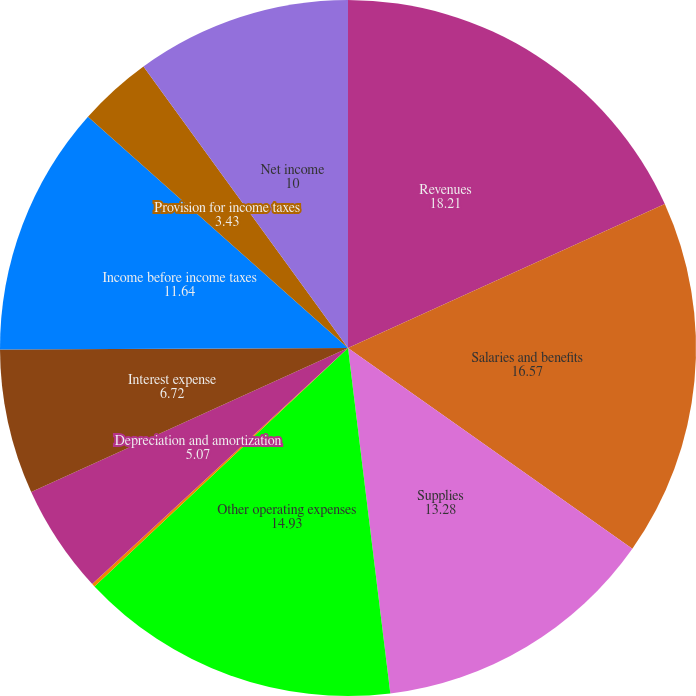Convert chart to OTSL. <chart><loc_0><loc_0><loc_500><loc_500><pie_chart><fcel>Revenues<fcel>Salaries and benefits<fcel>Supplies<fcel>Other operating expenses<fcel>Equity in earnings of<fcel>Depreciation and amortization<fcel>Interest expense<fcel>Income before income taxes<fcel>Provision for income taxes<fcel>Net income<nl><fcel>18.21%<fcel>16.57%<fcel>13.28%<fcel>14.93%<fcel>0.15%<fcel>5.07%<fcel>6.72%<fcel>11.64%<fcel>3.43%<fcel>10.0%<nl></chart> 